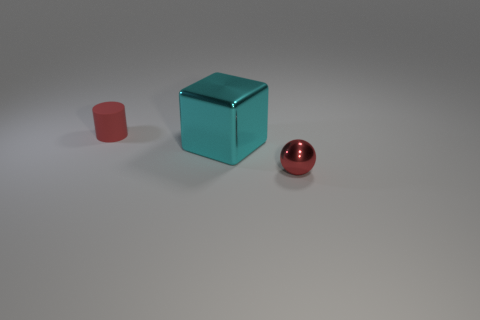Subtract all brown cylinders. Subtract all red blocks. How many cylinders are left? 1 Add 2 metallic objects. How many objects exist? 5 Subtract all balls. How many objects are left? 2 Subtract all small yellow matte cubes. Subtract all big shiny objects. How many objects are left? 2 Add 2 red matte cylinders. How many red matte cylinders are left? 3 Add 2 tiny spheres. How many tiny spheres exist? 3 Subtract 0 brown cubes. How many objects are left? 3 